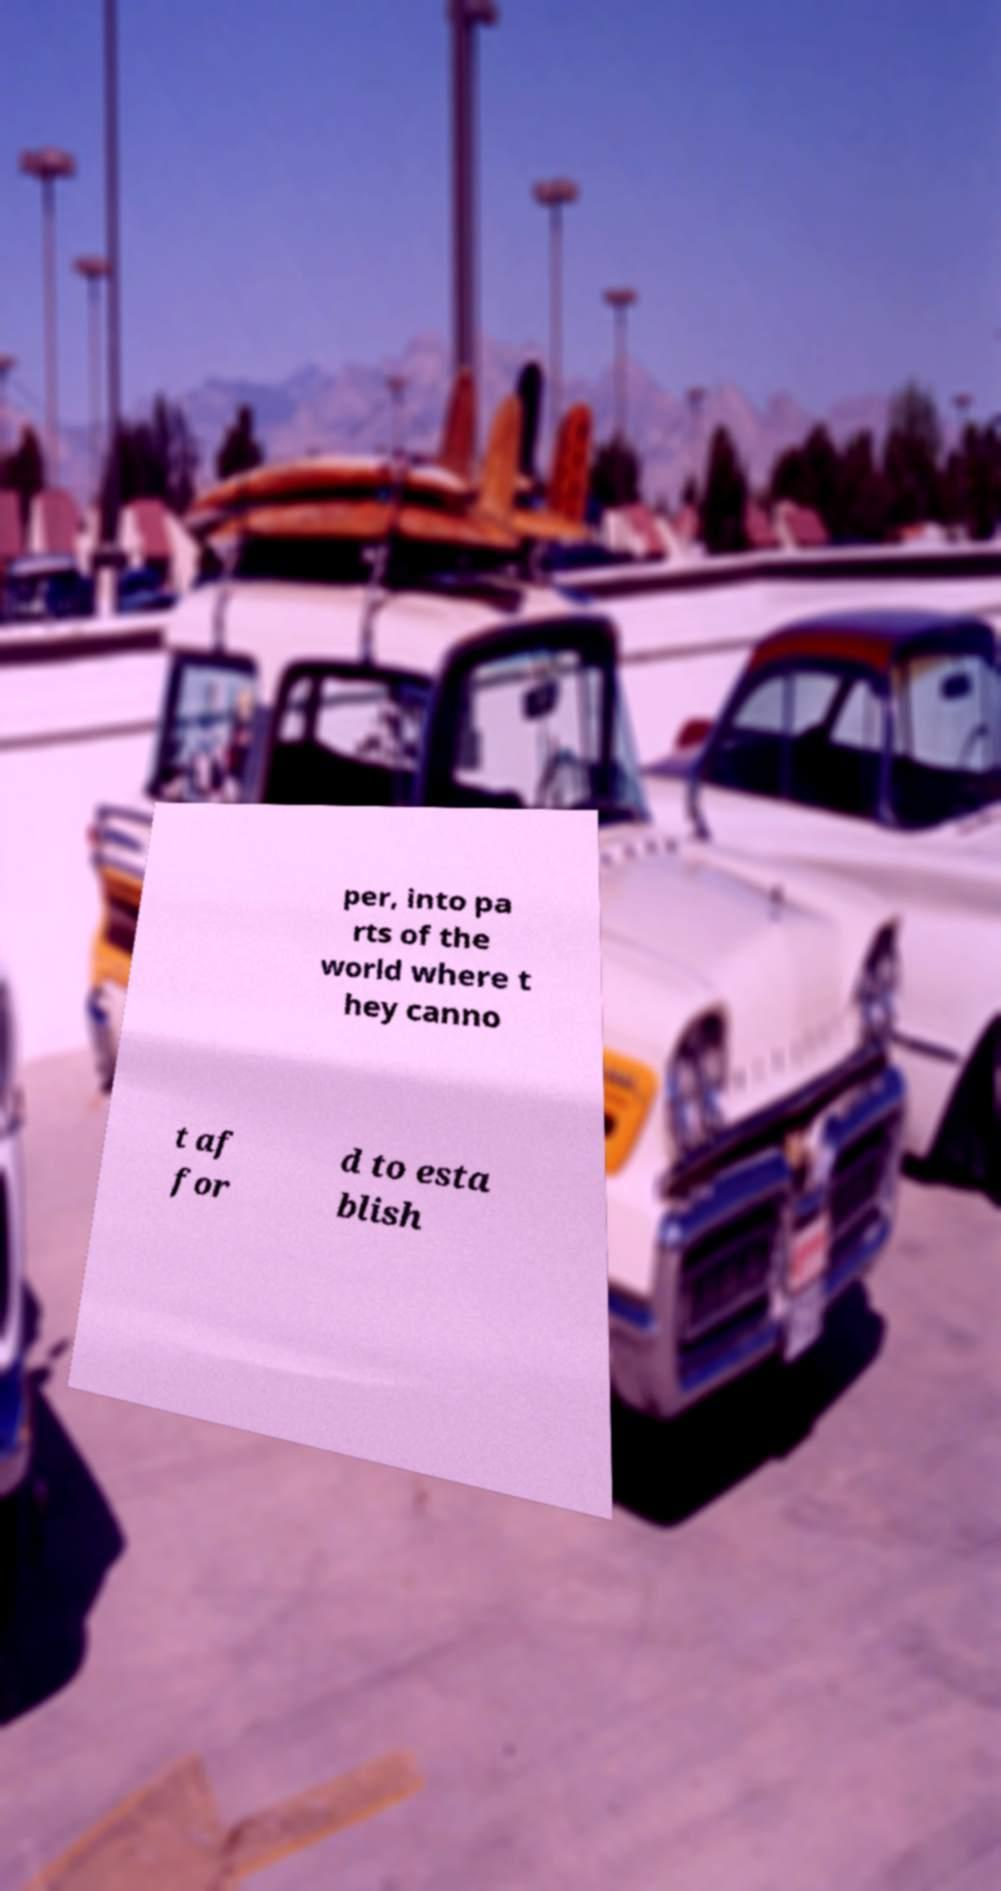I need the written content from this picture converted into text. Can you do that? per, into pa rts of the world where t hey canno t af for d to esta blish 